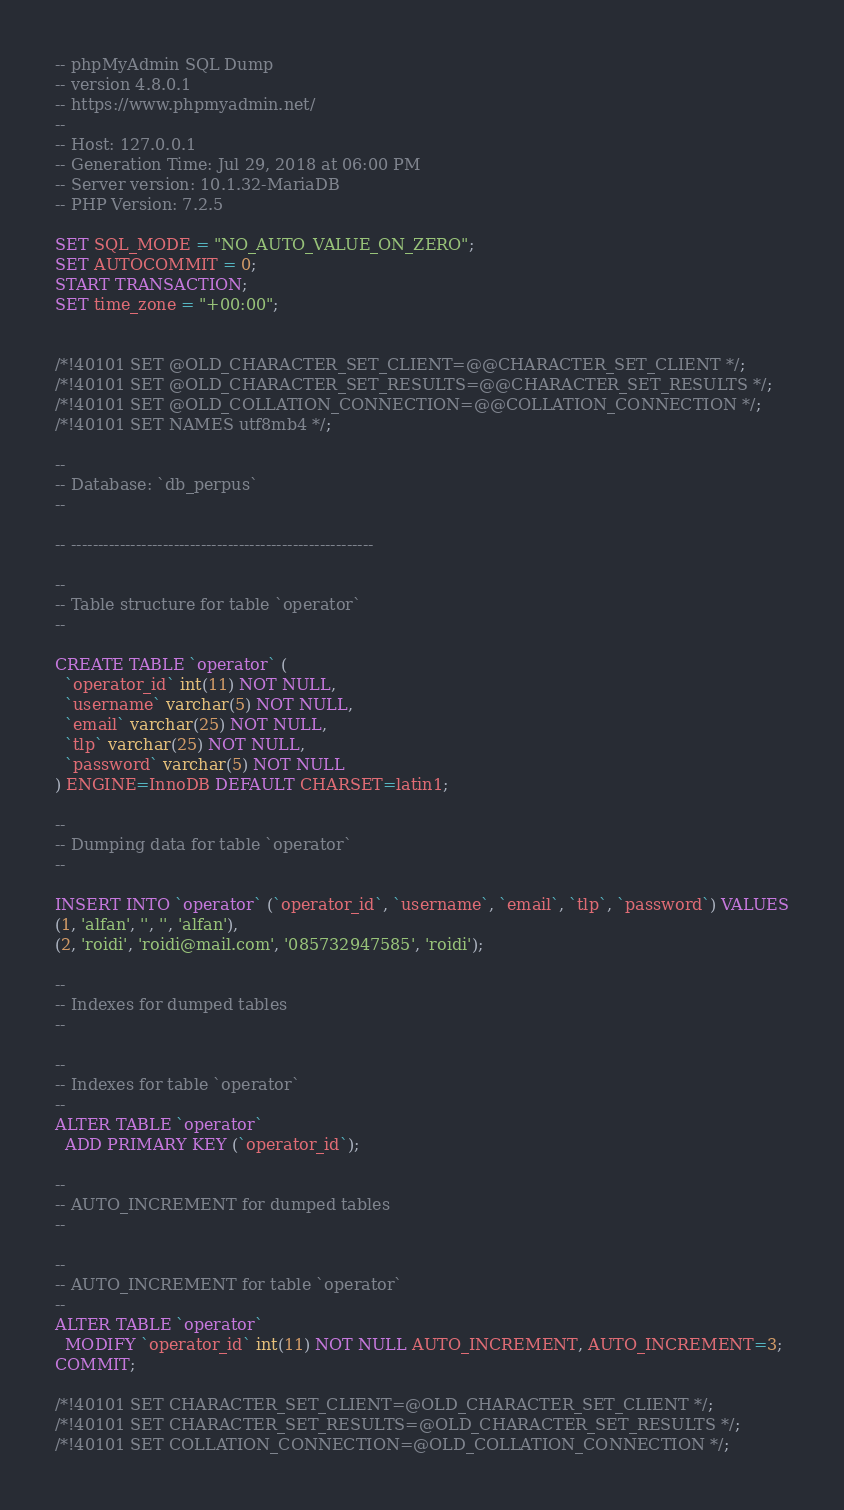<code> <loc_0><loc_0><loc_500><loc_500><_SQL_>-- phpMyAdmin SQL Dump
-- version 4.8.0.1
-- https://www.phpmyadmin.net/
--
-- Host: 127.0.0.1
-- Generation Time: Jul 29, 2018 at 06:00 PM
-- Server version: 10.1.32-MariaDB
-- PHP Version: 7.2.5

SET SQL_MODE = "NO_AUTO_VALUE_ON_ZERO";
SET AUTOCOMMIT = 0;
START TRANSACTION;
SET time_zone = "+00:00";


/*!40101 SET @OLD_CHARACTER_SET_CLIENT=@@CHARACTER_SET_CLIENT */;
/*!40101 SET @OLD_CHARACTER_SET_RESULTS=@@CHARACTER_SET_RESULTS */;
/*!40101 SET @OLD_COLLATION_CONNECTION=@@COLLATION_CONNECTION */;
/*!40101 SET NAMES utf8mb4 */;

--
-- Database: `db_perpus`
--

-- --------------------------------------------------------

--
-- Table structure for table `operator`
--

CREATE TABLE `operator` (
  `operator_id` int(11) NOT NULL,
  `username` varchar(5) NOT NULL,
  `email` varchar(25) NOT NULL,
  `tlp` varchar(25) NOT NULL,
  `password` varchar(5) NOT NULL
) ENGINE=InnoDB DEFAULT CHARSET=latin1;

--
-- Dumping data for table `operator`
--

INSERT INTO `operator` (`operator_id`, `username`, `email`, `tlp`, `password`) VALUES
(1, 'alfan', '', '', 'alfan'),
(2, 'roidi', 'roidi@mail.com', '085732947585', 'roidi');

--
-- Indexes for dumped tables
--

--
-- Indexes for table `operator`
--
ALTER TABLE `operator`
  ADD PRIMARY KEY (`operator_id`);

--
-- AUTO_INCREMENT for dumped tables
--

--
-- AUTO_INCREMENT for table `operator`
--
ALTER TABLE `operator`
  MODIFY `operator_id` int(11) NOT NULL AUTO_INCREMENT, AUTO_INCREMENT=3;
COMMIT;

/*!40101 SET CHARACTER_SET_CLIENT=@OLD_CHARACTER_SET_CLIENT */;
/*!40101 SET CHARACTER_SET_RESULTS=@OLD_CHARACTER_SET_RESULTS */;
/*!40101 SET COLLATION_CONNECTION=@OLD_COLLATION_CONNECTION */;
</code> 